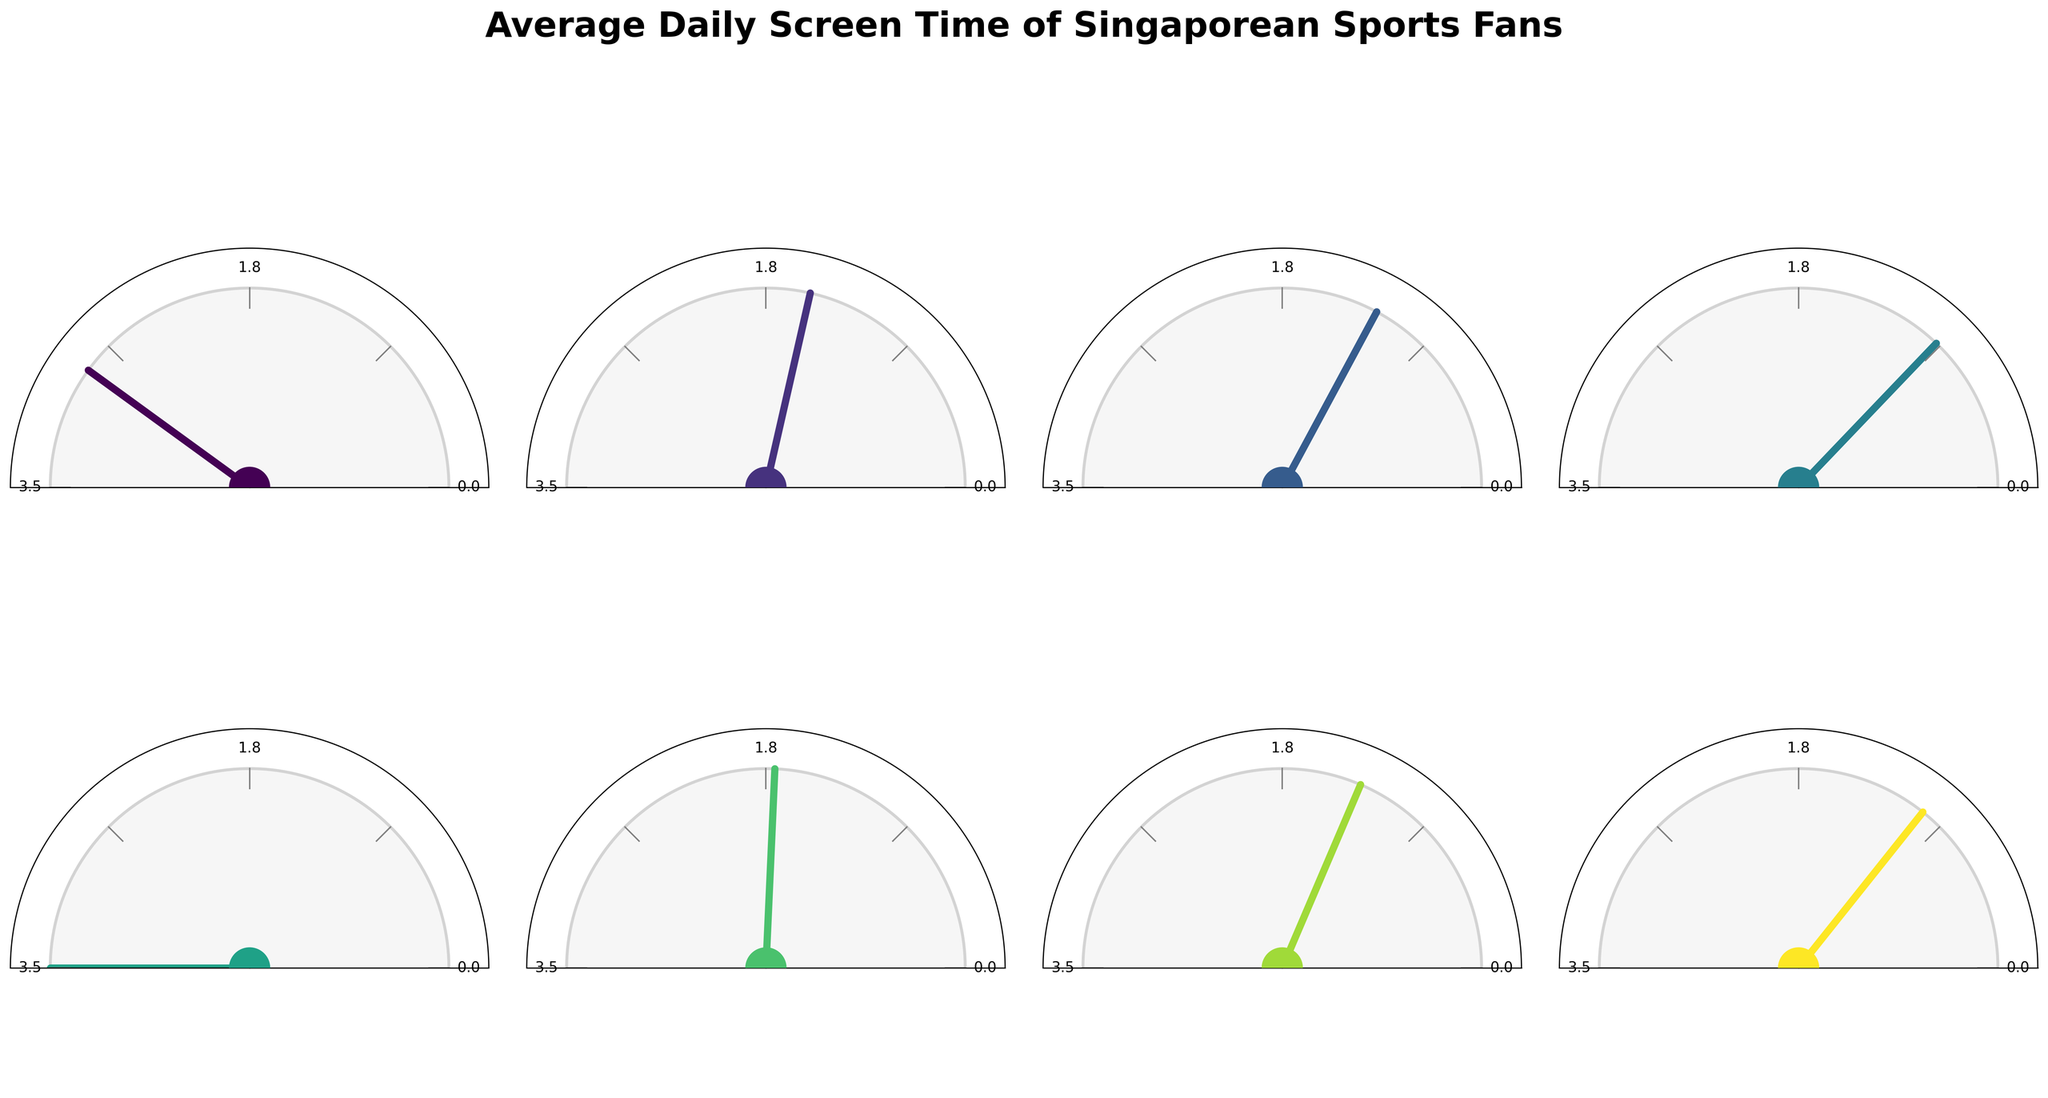What's the sport with the highest average daily screen time? The figure illustrates multiple gauges, each representing a sport and its corresponding average daily screen time. By observing the lengths of the arcs on the gauges, we see that eSports has the longest arc, indicating the highest value.
Answer: eSports What's the combined average daily screen time for Basketball and Tennis? From the figure, Basketball has an average daily screen time of 1.5 hours and Tennis has 1.2 hours. Adding these together gives 1.5 + 1.2.
Answer: 2.7 hours Which sports have an average daily screen time of less than 1 hour? By examining each gauge, you can see the sports that do not reach the 1-hour mark on their respective scales. In this figure, Swimming and Table Tennis both fall under the 1-hour mark.
Answer: Swimming, Table Tennis How much more screen time do Singaporean sports fans spend on Football compared to Badminton? Observing the figure, the gauge for Football shows 2.8 hours, and the gauge for Badminton shows 1.3 hours. Subtracting these values gives 2.8 - 1.3.
Answer: 1.5 hours Which sport has the closest average daily screen time to the overall maximum, and what is its value? The gauge for eSports is the one that reaches the overall maximum screen time, indicating that it is closest to the maximum value. This value is provided beneath the gauge for eSports.
Answer: eSports, 3.5 hours What's the average screen time across all sports? To calculate the average, sum all the average daily screen times and divide by the number of sports. The values are Football (2.8), Basketball (1.5), Tennis (1.2), Swimming (0.9), eSports (3.5), Formula 1 (1.7), Badminton (1.3), and Table Tennis (1.0). The sum is 2.8 + 1.5 + 1.2 + 0.9 + 3.5 + 1.7 + 1.3 + 1.0 = 13.9. Dividing by 8 gives the average.
Answer: 1.74 hours Are there more sports with an average daily screen time above 1.5 hours or below 1.5 hours? Categorize the sports by their average daily screen times. Above 1.5 hours: Football (2.8), eSports (3.5), and Formula 1 (1.7), totals 3 sports. Below 1.5 hours: Basketball (1.5), Tennis (1.2), Swimming (0.9), Badminton (1.3), and Table Tennis (1.0), totals 5 sports. Compare the counts.
Answer: Below, 5 sports Which sport has an average daily screen time closest to 1.6 hours? Observing and comparing the gauges, Formula 1 with an average screen time of 1.7 hours is the closest to 1.6 hours.
Answer: Formula 1 